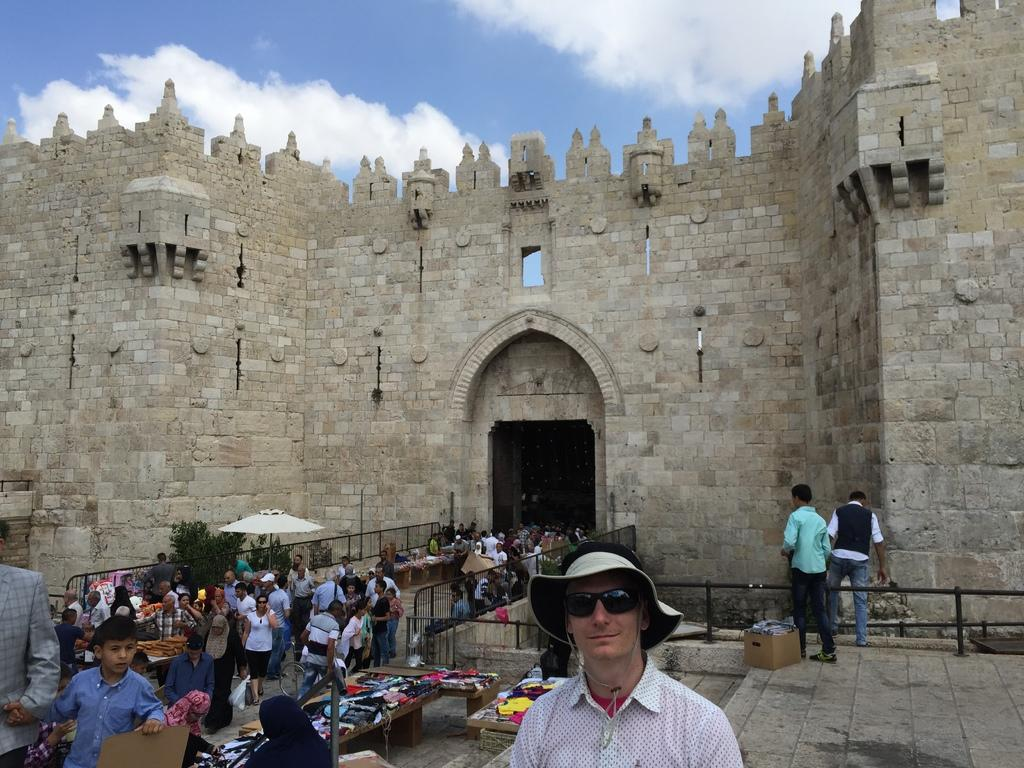What type of structure is visible in the image? There is a fort in the image. What is happening in front of the fort? There are groups of people and barricades in front of the fort. Can you describe any specific objects in front of the fort? There is an umbrella and an umbrella in front of the fort, as well as other unspecified objects. What can be seen in the background of the image? The sky is visible in the background of the image. What color is the vein in the hand of the person holding the umbrella in the image? There is no person holding an umbrella in the image, and therefore no vein or hand can be observed. 